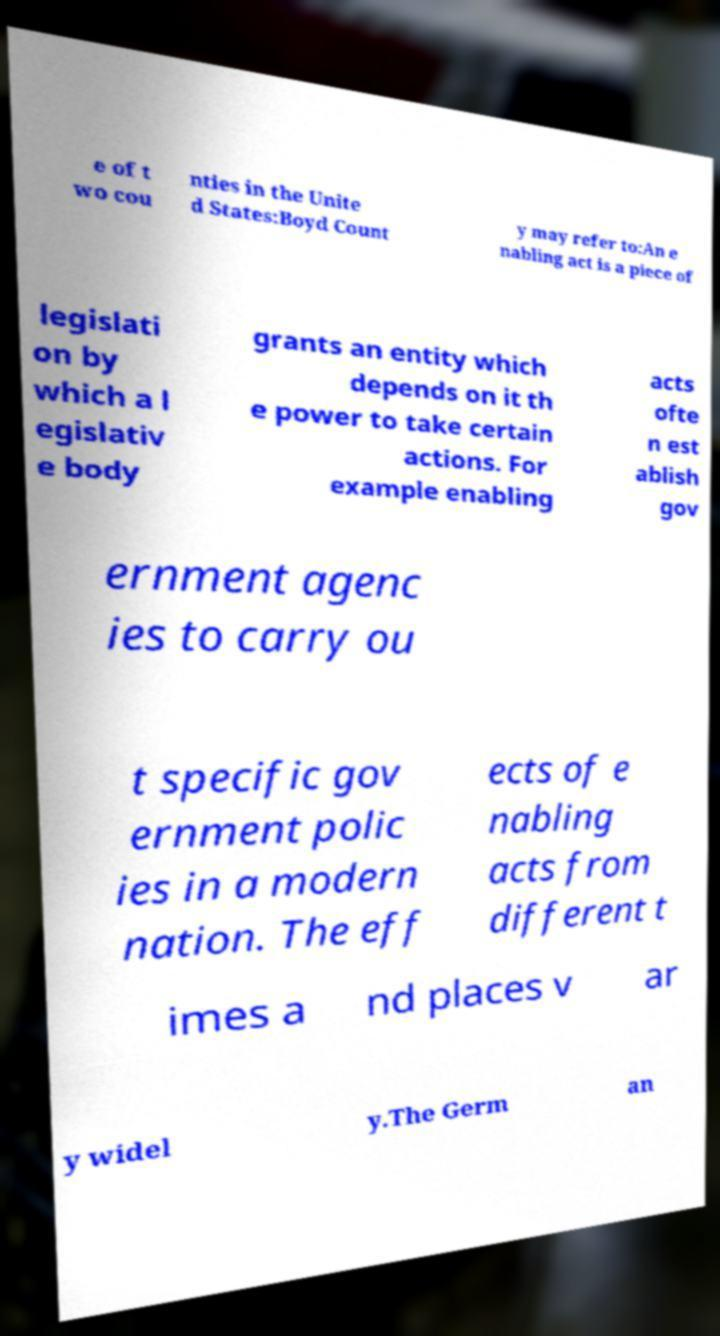There's text embedded in this image that I need extracted. Can you transcribe it verbatim? e of t wo cou nties in the Unite d States:Boyd Count y may refer to:An e nabling act is a piece of legislati on by which a l egislativ e body grants an entity which depends on it th e power to take certain actions. For example enabling acts ofte n est ablish gov ernment agenc ies to carry ou t specific gov ernment polic ies in a modern nation. The eff ects of e nabling acts from different t imes a nd places v ar y widel y.The Germ an 